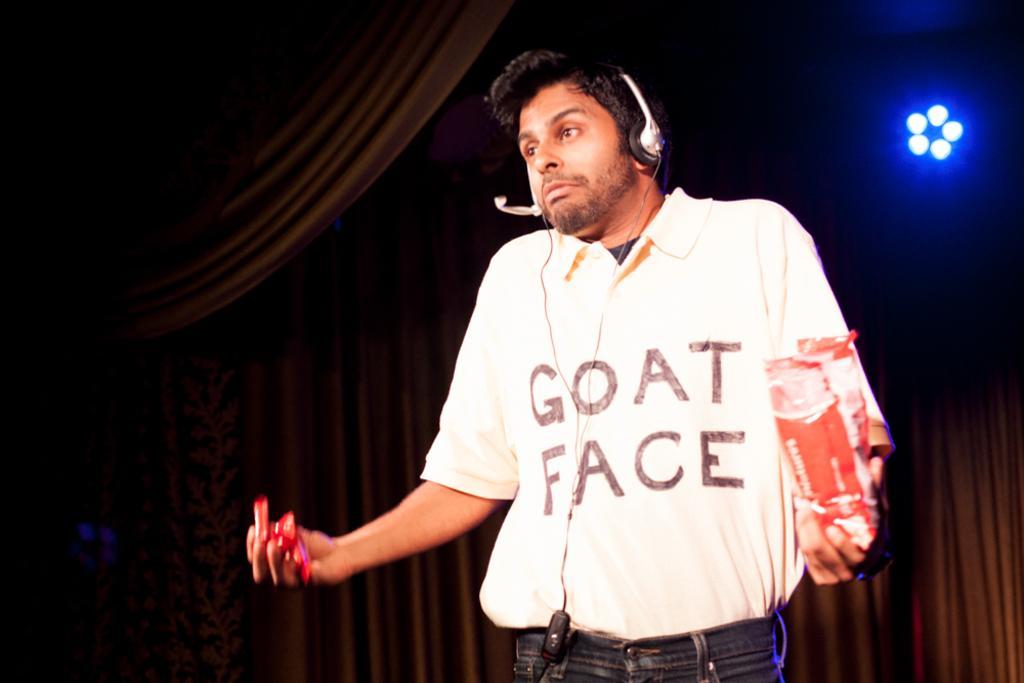Can you describe this image briefly? In this picture I can see a man standing and he wore a headset and he is holding a cover in one hand and few candies in another hand and few clothes on the back and lights. 